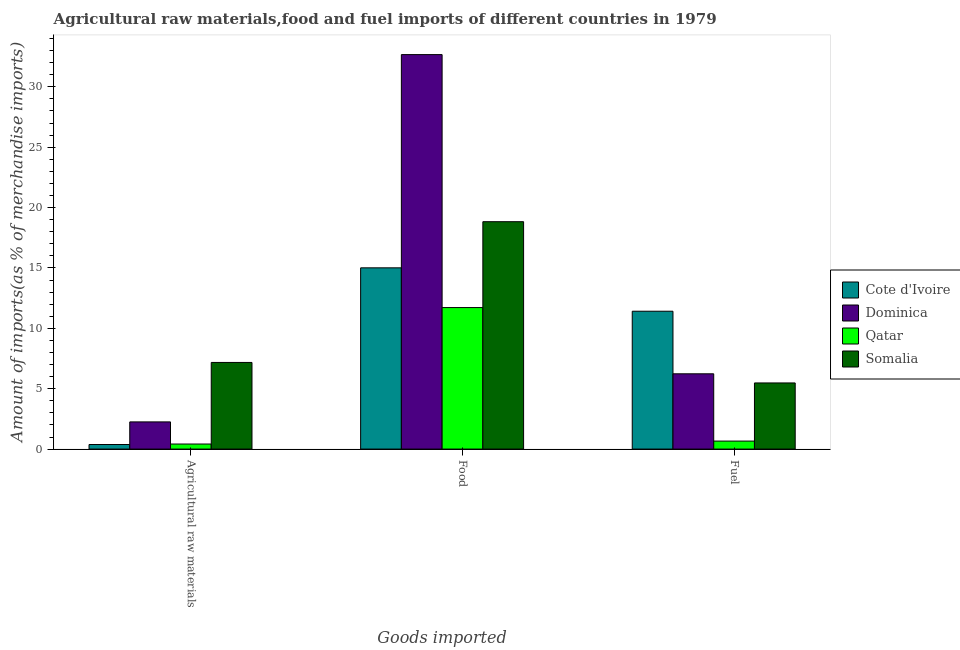How many different coloured bars are there?
Make the answer very short. 4. How many bars are there on the 2nd tick from the left?
Ensure brevity in your answer.  4. What is the label of the 1st group of bars from the left?
Your answer should be very brief. Agricultural raw materials. What is the percentage of fuel imports in Somalia?
Ensure brevity in your answer.  5.48. Across all countries, what is the maximum percentage of food imports?
Make the answer very short. 32.67. Across all countries, what is the minimum percentage of fuel imports?
Offer a terse response. 0.66. In which country was the percentage of fuel imports maximum?
Give a very brief answer. Cote d'Ivoire. In which country was the percentage of fuel imports minimum?
Your answer should be very brief. Qatar. What is the total percentage of food imports in the graph?
Your answer should be very brief. 78.23. What is the difference between the percentage of raw materials imports in Qatar and that in Somalia?
Your answer should be compact. -6.76. What is the difference between the percentage of food imports in Cote d'Ivoire and the percentage of fuel imports in Qatar?
Your response must be concise. 14.35. What is the average percentage of fuel imports per country?
Your answer should be compact. 5.95. What is the difference between the percentage of raw materials imports and percentage of food imports in Somalia?
Provide a short and direct response. -11.66. What is the ratio of the percentage of food imports in Somalia to that in Dominica?
Your answer should be very brief. 0.58. Is the percentage of food imports in Qatar less than that in Cote d'Ivoire?
Provide a succinct answer. Yes. What is the difference between the highest and the second highest percentage of raw materials imports?
Your answer should be very brief. 4.92. What is the difference between the highest and the lowest percentage of food imports?
Give a very brief answer. 20.95. In how many countries, is the percentage of food imports greater than the average percentage of food imports taken over all countries?
Ensure brevity in your answer.  1. Is the sum of the percentage of food imports in Qatar and Somalia greater than the maximum percentage of raw materials imports across all countries?
Your answer should be compact. Yes. What does the 1st bar from the left in Fuel represents?
Offer a terse response. Cote d'Ivoire. What does the 1st bar from the right in Agricultural raw materials represents?
Your response must be concise. Somalia. How many bars are there?
Offer a very short reply. 12. Are all the bars in the graph horizontal?
Provide a short and direct response. No. How many countries are there in the graph?
Your response must be concise. 4. What is the difference between two consecutive major ticks on the Y-axis?
Provide a short and direct response. 5. Does the graph contain any zero values?
Provide a succinct answer. No. What is the title of the graph?
Ensure brevity in your answer.  Agricultural raw materials,food and fuel imports of different countries in 1979. Does "Russian Federation" appear as one of the legend labels in the graph?
Your answer should be very brief. No. What is the label or title of the X-axis?
Keep it short and to the point. Goods imported. What is the label or title of the Y-axis?
Your response must be concise. Amount of imports(as % of merchandise imports). What is the Amount of imports(as % of merchandise imports) of Cote d'Ivoire in Agricultural raw materials?
Keep it short and to the point. 0.38. What is the Amount of imports(as % of merchandise imports) of Dominica in Agricultural raw materials?
Offer a terse response. 2.25. What is the Amount of imports(as % of merchandise imports) of Qatar in Agricultural raw materials?
Your answer should be very brief. 0.42. What is the Amount of imports(as % of merchandise imports) of Somalia in Agricultural raw materials?
Your answer should be compact. 7.17. What is the Amount of imports(as % of merchandise imports) in Cote d'Ivoire in Food?
Make the answer very short. 15.01. What is the Amount of imports(as % of merchandise imports) in Dominica in Food?
Provide a succinct answer. 32.67. What is the Amount of imports(as % of merchandise imports) of Qatar in Food?
Your response must be concise. 11.72. What is the Amount of imports(as % of merchandise imports) of Somalia in Food?
Ensure brevity in your answer.  18.83. What is the Amount of imports(as % of merchandise imports) in Cote d'Ivoire in Fuel?
Give a very brief answer. 11.42. What is the Amount of imports(as % of merchandise imports) in Dominica in Fuel?
Make the answer very short. 6.23. What is the Amount of imports(as % of merchandise imports) of Qatar in Fuel?
Your answer should be very brief. 0.66. What is the Amount of imports(as % of merchandise imports) of Somalia in Fuel?
Make the answer very short. 5.48. Across all Goods imported, what is the maximum Amount of imports(as % of merchandise imports) of Cote d'Ivoire?
Ensure brevity in your answer.  15.01. Across all Goods imported, what is the maximum Amount of imports(as % of merchandise imports) of Dominica?
Keep it short and to the point. 32.67. Across all Goods imported, what is the maximum Amount of imports(as % of merchandise imports) of Qatar?
Ensure brevity in your answer.  11.72. Across all Goods imported, what is the maximum Amount of imports(as % of merchandise imports) in Somalia?
Ensure brevity in your answer.  18.83. Across all Goods imported, what is the minimum Amount of imports(as % of merchandise imports) of Cote d'Ivoire?
Give a very brief answer. 0.38. Across all Goods imported, what is the minimum Amount of imports(as % of merchandise imports) in Dominica?
Offer a terse response. 2.25. Across all Goods imported, what is the minimum Amount of imports(as % of merchandise imports) in Qatar?
Offer a very short reply. 0.42. Across all Goods imported, what is the minimum Amount of imports(as % of merchandise imports) in Somalia?
Your answer should be very brief. 5.48. What is the total Amount of imports(as % of merchandise imports) of Cote d'Ivoire in the graph?
Your answer should be very brief. 26.8. What is the total Amount of imports(as % of merchandise imports) in Dominica in the graph?
Offer a very short reply. 41.15. What is the total Amount of imports(as % of merchandise imports) of Qatar in the graph?
Offer a terse response. 12.8. What is the total Amount of imports(as % of merchandise imports) in Somalia in the graph?
Your answer should be very brief. 31.48. What is the difference between the Amount of imports(as % of merchandise imports) of Cote d'Ivoire in Agricultural raw materials and that in Food?
Give a very brief answer. -14.63. What is the difference between the Amount of imports(as % of merchandise imports) in Dominica in Agricultural raw materials and that in Food?
Make the answer very short. -30.42. What is the difference between the Amount of imports(as % of merchandise imports) in Qatar in Agricultural raw materials and that in Food?
Give a very brief answer. -11.3. What is the difference between the Amount of imports(as % of merchandise imports) of Somalia in Agricultural raw materials and that in Food?
Offer a very short reply. -11.66. What is the difference between the Amount of imports(as % of merchandise imports) in Cote d'Ivoire in Agricultural raw materials and that in Fuel?
Your answer should be compact. -11.04. What is the difference between the Amount of imports(as % of merchandise imports) in Dominica in Agricultural raw materials and that in Fuel?
Your answer should be compact. -3.98. What is the difference between the Amount of imports(as % of merchandise imports) of Qatar in Agricultural raw materials and that in Fuel?
Give a very brief answer. -0.24. What is the difference between the Amount of imports(as % of merchandise imports) of Somalia in Agricultural raw materials and that in Fuel?
Your response must be concise. 1.7. What is the difference between the Amount of imports(as % of merchandise imports) in Cote d'Ivoire in Food and that in Fuel?
Ensure brevity in your answer.  3.59. What is the difference between the Amount of imports(as % of merchandise imports) in Dominica in Food and that in Fuel?
Provide a succinct answer. 26.44. What is the difference between the Amount of imports(as % of merchandise imports) in Qatar in Food and that in Fuel?
Give a very brief answer. 11.06. What is the difference between the Amount of imports(as % of merchandise imports) of Somalia in Food and that in Fuel?
Make the answer very short. 13.35. What is the difference between the Amount of imports(as % of merchandise imports) in Cote d'Ivoire in Agricultural raw materials and the Amount of imports(as % of merchandise imports) in Dominica in Food?
Your response must be concise. -32.29. What is the difference between the Amount of imports(as % of merchandise imports) of Cote d'Ivoire in Agricultural raw materials and the Amount of imports(as % of merchandise imports) of Qatar in Food?
Your answer should be compact. -11.34. What is the difference between the Amount of imports(as % of merchandise imports) in Cote d'Ivoire in Agricultural raw materials and the Amount of imports(as % of merchandise imports) in Somalia in Food?
Give a very brief answer. -18.45. What is the difference between the Amount of imports(as % of merchandise imports) of Dominica in Agricultural raw materials and the Amount of imports(as % of merchandise imports) of Qatar in Food?
Provide a succinct answer. -9.47. What is the difference between the Amount of imports(as % of merchandise imports) of Dominica in Agricultural raw materials and the Amount of imports(as % of merchandise imports) of Somalia in Food?
Offer a terse response. -16.58. What is the difference between the Amount of imports(as % of merchandise imports) in Qatar in Agricultural raw materials and the Amount of imports(as % of merchandise imports) in Somalia in Food?
Provide a short and direct response. -18.41. What is the difference between the Amount of imports(as % of merchandise imports) in Cote d'Ivoire in Agricultural raw materials and the Amount of imports(as % of merchandise imports) in Dominica in Fuel?
Your answer should be very brief. -5.86. What is the difference between the Amount of imports(as % of merchandise imports) of Cote d'Ivoire in Agricultural raw materials and the Amount of imports(as % of merchandise imports) of Qatar in Fuel?
Keep it short and to the point. -0.28. What is the difference between the Amount of imports(as % of merchandise imports) in Cote d'Ivoire in Agricultural raw materials and the Amount of imports(as % of merchandise imports) in Somalia in Fuel?
Keep it short and to the point. -5.1. What is the difference between the Amount of imports(as % of merchandise imports) in Dominica in Agricultural raw materials and the Amount of imports(as % of merchandise imports) in Qatar in Fuel?
Ensure brevity in your answer.  1.59. What is the difference between the Amount of imports(as % of merchandise imports) of Dominica in Agricultural raw materials and the Amount of imports(as % of merchandise imports) of Somalia in Fuel?
Your response must be concise. -3.23. What is the difference between the Amount of imports(as % of merchandise imports) in Qatar in Agricultural raw materials and the Amount of imports(as % of merchandise imports) in Somalia in Fuel?
Provide a succinct answer. -5.06. What is the difference between the Amount of imports(as % of merchandise imports) of Cote d'Ivoire in Food and the Amount of imports(as % of merchandise imports) of Dominica in Fuel?
Make the answer very short. 8.78. What is the difference between the Amount of imports(as % of merchandise imports) in Cote d'Ivoire in Food and the Amount of imports(as % of merchandise imports) in Qatar in Fuel?
Your answer should be compact. 14.35. What is the difference between the Amount of imports(as % of merchandise imports) in Cote d'Ivoire in Food and the Amount of imports(as % of merchandise imports) in Somalia in Fuel?
Your answer should be compact. 9.53. What is the difference between the Amount of imports(as % of merchandise imports) of Dominica in Food and the Amount of imports(as % of merchandise imports) of Qatar in Fuel?
Give a very brief answer. 32.01. What is the difference between the Amount of imports(as % of merchandise imports) of Dominica in Food and the Amount of imports(as % of merchandise imports) of Somalia in Fuel?
Offer a very short reply. 27.19. What is the difference between the Amount of imports(as % of merchandise imports) of Qatar in Food and the Amount of imports(as % of merchandise imports) of Somalia in Fuel?
Give a very brief answer. 6.24. What is the average Amount of imports(as % of merchandise imports) of Cote d'Ivoire per Goods imported?
Make the answer very short. 8.94. What is the average Amount of imports(as % of merchandise imports) in Dominica per Goods imported?
Offer a terse response. 13.72. What is the average Amount of imports(as % of merchandise imports) in Qatar per Goods imported?
Keep it short and to the point. 4.27. What is the average Amount of imports(as % of merchandise imports) in Somalia per Goods imported?
Your answer should be compact. 10.49. What is the difference between the Amount of imports(as % of merchandise imports) of Cote d'Ivoire and Amount of imports(as % of merchandise imports) of Dominica in Agricultural raw materials?
Your answer should be compact. -1.87. What is the difference between the Amount of imports(as % of merchandise imports) of Cote d'Ivoire and Amount of imports(as % of merchandise imports) of Qatar in Agricultural raw materials?
Your answer should be compact. -0.04. What is the difference between the Amount of imports(as % of merchandise imports) of Cote d'Ivoire and Amount of imports(as % of merchandise imports) of Somalia in Agricultural raw materials?
Your answer should be compact. -6.8. What is the difference between the Amount of imports(as % of merchandise imports) of Dominica and Amount of imports(as % of merchandise imports) of Qatar in Agricultural raw materials?
Offer a very short reply. 1.83. What is the difference between the Amount of imports(as % of merchandise imports) in Dominica and Amount of imports(as % of merchandise imports) in Somalia in Agricultural raw materials?
Your answer should be compact. -4.92. What is the difference between the Amount of imports(as % of merchandise imports) of Qatar and Amount of imports(as % of merchandise imports) of Somalia in Agricultural raw materials?
Keep it short and to the point. -6.76. What is the difference between the Amount of imports(as % of merchandise imports) of Cote d'Ivoire and Amount of imports(as % of merchandise imports) of Dominica in Food?
Your answer should be compact. -17.66. What is the difference between the Amount of imports(as % of merchandise imports) of Cote d'Ivoire and Amount of imports(as % of merchandise imports) of Qatar in Food?
Provide a short and direct response. 3.29. What is the difference between the Amount of imports(as % of merchandise imports) of Cote d'Ivoire and Amount of imports(as % of merchandise imports) of Somalia in Food?
Offer a very short reply. -3.82. What is the difference between the Amount of imports(as % of merchandise imports) in Dominica and Amount of imports(as % of merchandise imports) in Qatar in Food?
Offer a very short reply. 20.95. What is the difference between the Amount of imports(as % of merchandise imports) in Dominica and Amount of imports(as % of merchandise imports) in Somalia in Food?
Give a very brief answer. 13.84. What is the difference between the Amount of imports(as % of merchandise imports) in Qatar and Amount of imports(as % of merchandise imports) in Somalia in Food?
Provide a succinct answer. -7.11. What is the difference between the Amount of imports(as % of merchandise imports) in Cote d'Ivoire and Amount of imports(as % of merchandise imports) in Dominica in Fuel?
Offer a terse response. 5.18. What is the difference between the Amount of imports(as % of merchandise imports) of Cote d'Ivoire and Amount of imports(as % of merchandise imports) of Qatar in Fuel?
Offer a terse response. 10.75. What is the difference between the Amount of imports(as % of merchandise imports) of Cote d'Ivoire and Amount of imports(as % of merchandise imports) of Somalia in Fuel?
Ensure brevity in your answer.  5.94. What is the difference between the Amount of imports(as % of merchandise imports) of Dominica and Amount of imports(as % of merchandise imports) of Qatar in Fuel?
Provide a succinct answer. 5.57. What is the difference between the Amount of imports(as % of merchandise imports) of Dominica and Amount of imports(as % of merchandise imports) of Somalia in Fuel?
Give a very brief answer. 0.76. What is the difference between the Amount of imports(as % of merchandise imports) of Qatar and Amount of imports(as % of merchandise imports) of Somalia in Fuel?
Provide a short and direct response. -4.81. What is the ratio of the Amount of imports(as % of merchandise imports) of Cote d'Ivoire in Agricultural raw materials to that in Food?
Keep it short and to the point. 0.03. What is the ratio of the Amount of imports(as % of merchandise imports) in Dominica in Agricultural raw materials to that in Food?
Offer a terse response. 0.07. What is the ratio of the Amount of imports(as % of merchandise imports) in Qatar in Agricultural raw materials to that in Food?
Provide a short and direct response. 0.04. What is the ratio of the Amount of imports(as % of merchandise imports) in Somalia in Agricultural raw materials to that in Food?
Ensure brevity in your answer.  0.38. What is the ratio of the Amount of imports(as % of merchandise imports) of Cote d'Ivoire in Agricultural raw materials to that in Fuel?
Make the answer very short. 0.03. What is the ratio of the Amount of imports(as % of merchandise imports) of Dominica in Agricultural raw materials to that in Fuel?
Make the answer very short. 0.36. What is the ratio of the Amount of imports(as % of merchandise imports) of Qatar in Agricultural raw materials to that in Fuel?
Provide a short and direct response. 0.63. What is the ratio of the Amount of imports(as % of merchandise imports) of Somalia in Agricultural raw materials to that in Fuel?
Provide a short and direct response. 1.31. What is the ratio of the Amount of imports(as % of merchandise imports) in Cote d'Ivoire in Food to that in Fuel?
Your answer should be very brief. 1.31. What is the ratio of the Amount of imports(as % of merchandise imports) of Dominica in Food to that in Fuel?
Make the answer very short. 5.24. What is the ratio of the Amount of imports(as % of merchandise imports) in Qatar in Food to that in Fuel?
Provide a succinct answer. 17.71. What is the ratio of the Amount of imports(as % of merchandise imports) of Somalia in Food to that in Fuel?
Give a very brief answer. 3.44. What is the difference between the highest and the second highest Amount of imports(as % of merchandise imports) of Cote d'Ivoire?
Give a very brief answer. 3.59. What is the difference between the highest and the second highest Amount of imports(as % of merchandise imports) of Dominica?
Make the answer very short. 26.44. What is the difference between the highest and the second highest Amount of imports(as % of merchandise imports) of Qatar?
Offer a very short reply. 11.06. What is the difference between the highest and the second highest Amount of imports(as % of merchandise imports) in Somalia?
Your response must be concise. 11.66. What is the difference between the highest and the lowest Amount of imports(as % of merchandise imports) in Cote d'Ivoire?
Keep it short and to the point. 14.63. What is the difference between the highest and the lowest Amount of imports(as % of merchandise imports) in Dominica?
Your answer should be compact. 30.42. What is the difference between the highest and the lowest Amount of imports(as % of merchandise imports) of Qatar?
Make the answer very short. 11.3. What is the difference between the highest and the lowest Amount of imports(as % of merchandise imports) of Somalia?
Make the answer very short. 13.35. 